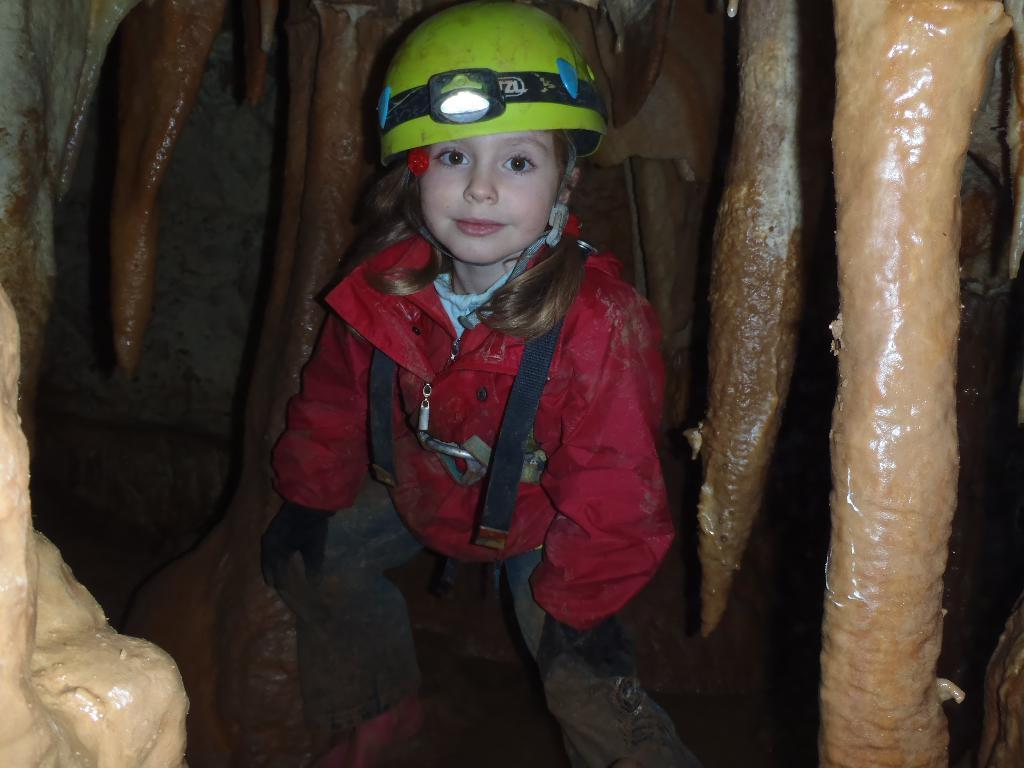Where was the image taken? The image is taken outdoors. Who is present in the image? There is a girl in the image. What is the setting of the image? The girl is in a cave, and there is a cave in the image. What time of day is it in the image, and how does the girl's quiver help her during this time? The provided facts do not mention the time of day, and there is no mention of a quiver in the image. 